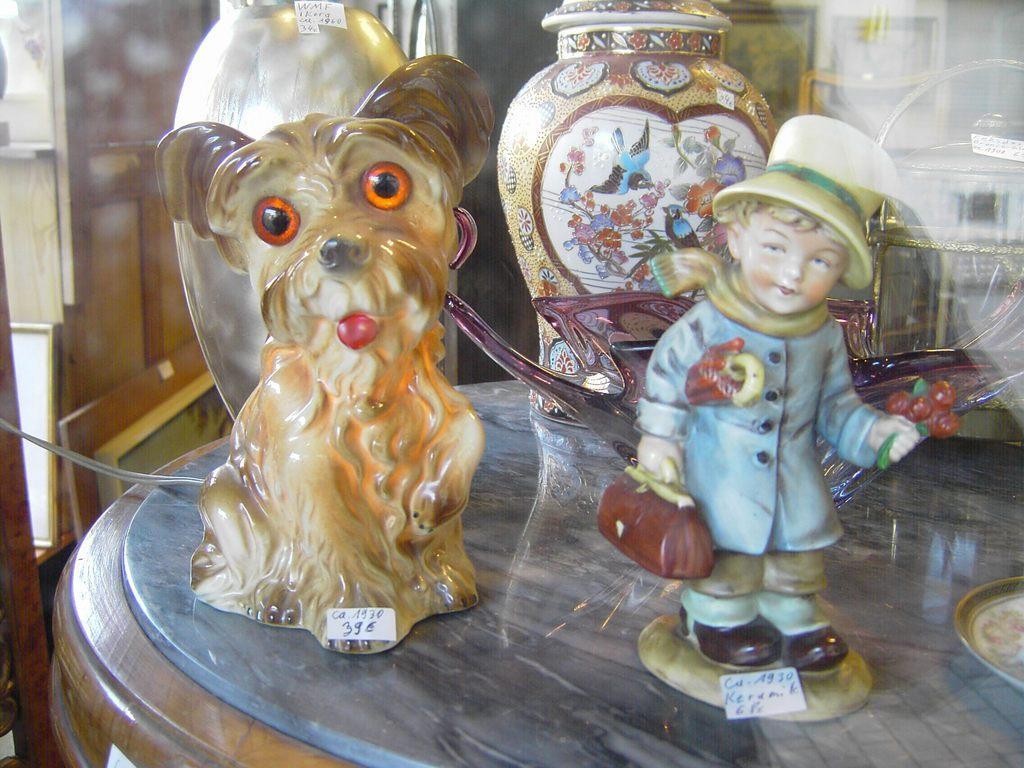In one or two sentences, can you explain what this image depicts? In this image there is a table on which there are two ceramic toys,bowl and two pots. In the background there is a wooden wall. Below the wall there is a photo frame. 